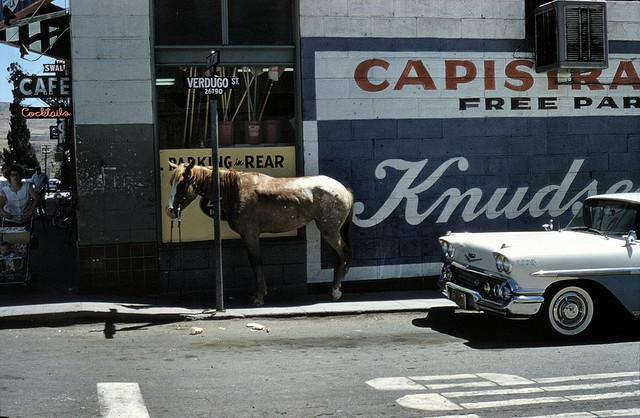This animal is frequently used as transportation by what profession?

Choices:
A) plumber
B) police officer
C) butcher
D) baker police officer 